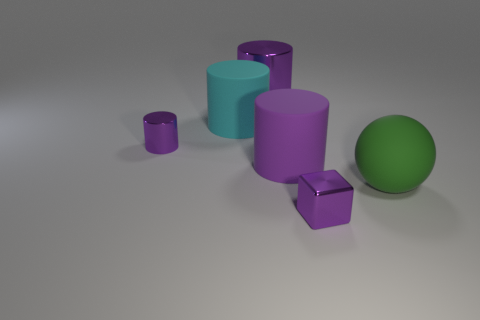Is there anything else that is the same color as the small cube?
Give a very brief answer. Yes. Is the number of large cyan rubber cylinders that are behind the large cyan cylinder less than the number of large blue shiny objects?
Your answer should be very brief. No. How many green rubber things have the same size as the green matte sphere?
Your answer should be compact. 0. There is a matte thing that is the same color as the small block; what is its shape?
Provide a short and direct response. Cylinder. There is a small thing to the right of the purple metallic object behind the metallic cylinder that is to the left of the cyan cylinder; what shape is it?
Your response must be concise. Cube. The object in front of the large rubber sphere is what color?
Your response must be concise. Purple. What number of things are either purple shiny objects that are behind the tiny purple shiny block or things that are to the left of the green sphere?
Ensure brevity in your answer.  5. What number of other large things are the same shape as the cyan rubber thing?
Give a very brief answer. 2. The metallic cylinder that is the same size as the purple rubber cylinder is what color?
Offer a terse response. Purple. The rubber cylinder behind the tiny object that is to the left of the tiny thing that is right of the big purple matte thing is what color?
Your response must be concise. Cyan. 